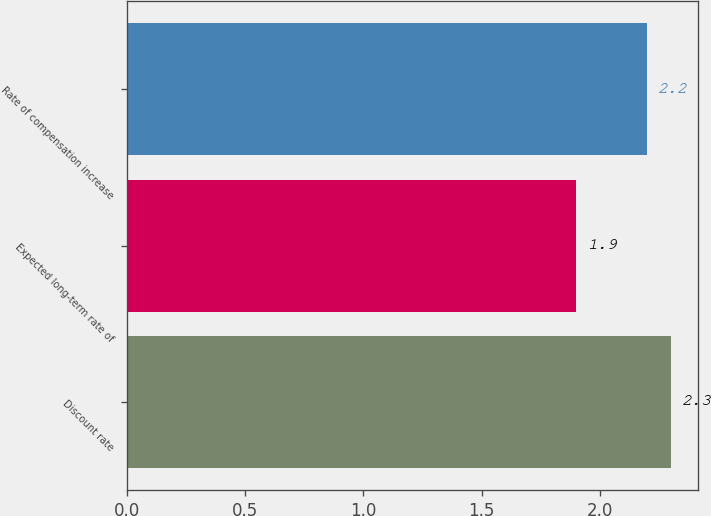<chart> <loc_0><loc_0><loc_500><loc_500><bar_chart><fcel>Discount rate<fcel>Expected long-term rate of<fcel>Rate of compensation increase<nl><fcel>2.3<fcel>1.9<fcel>2.2<nl></chart> 